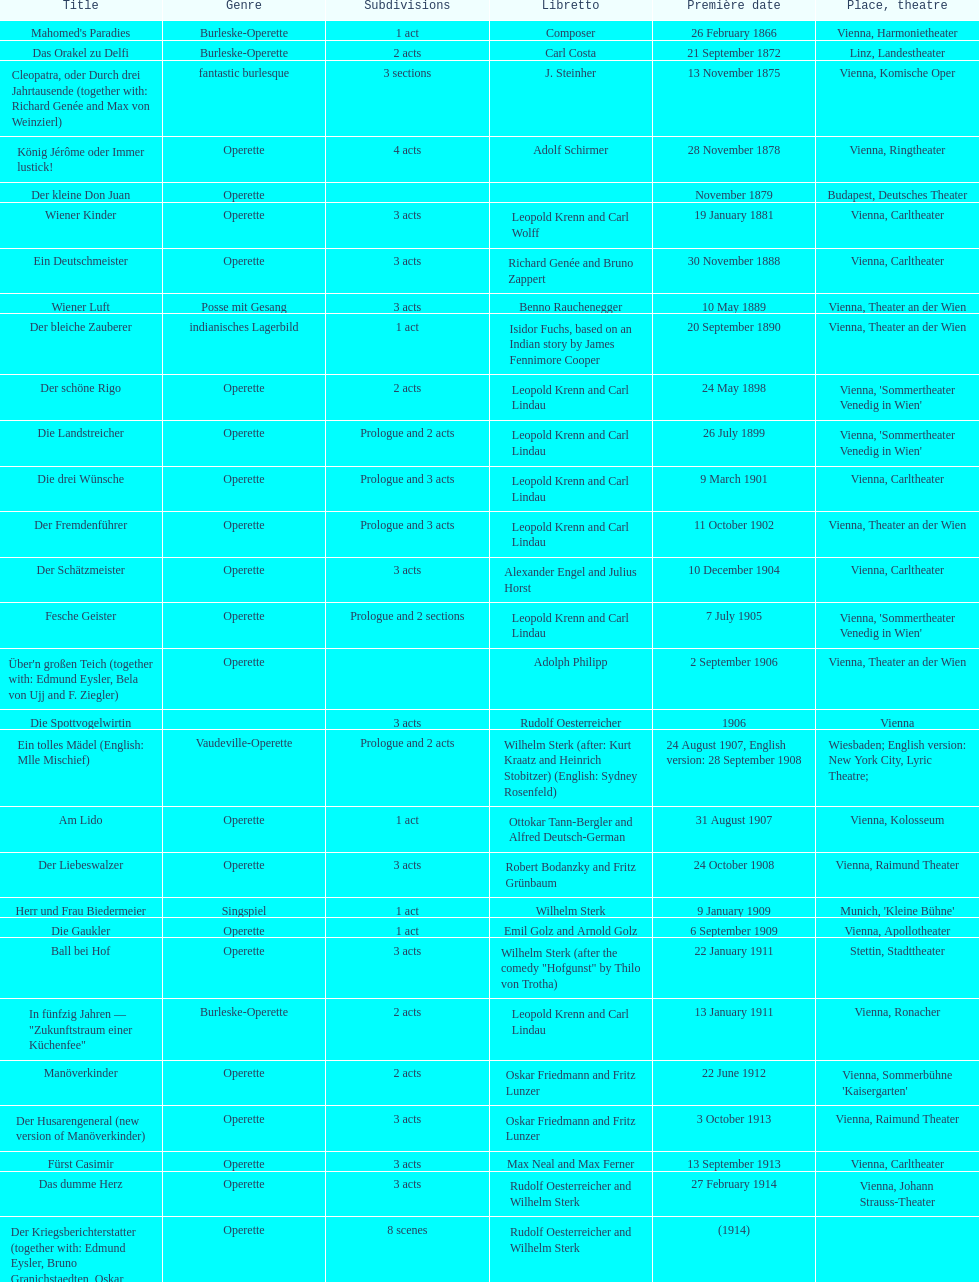All the dates are no later than what year? 1958. 